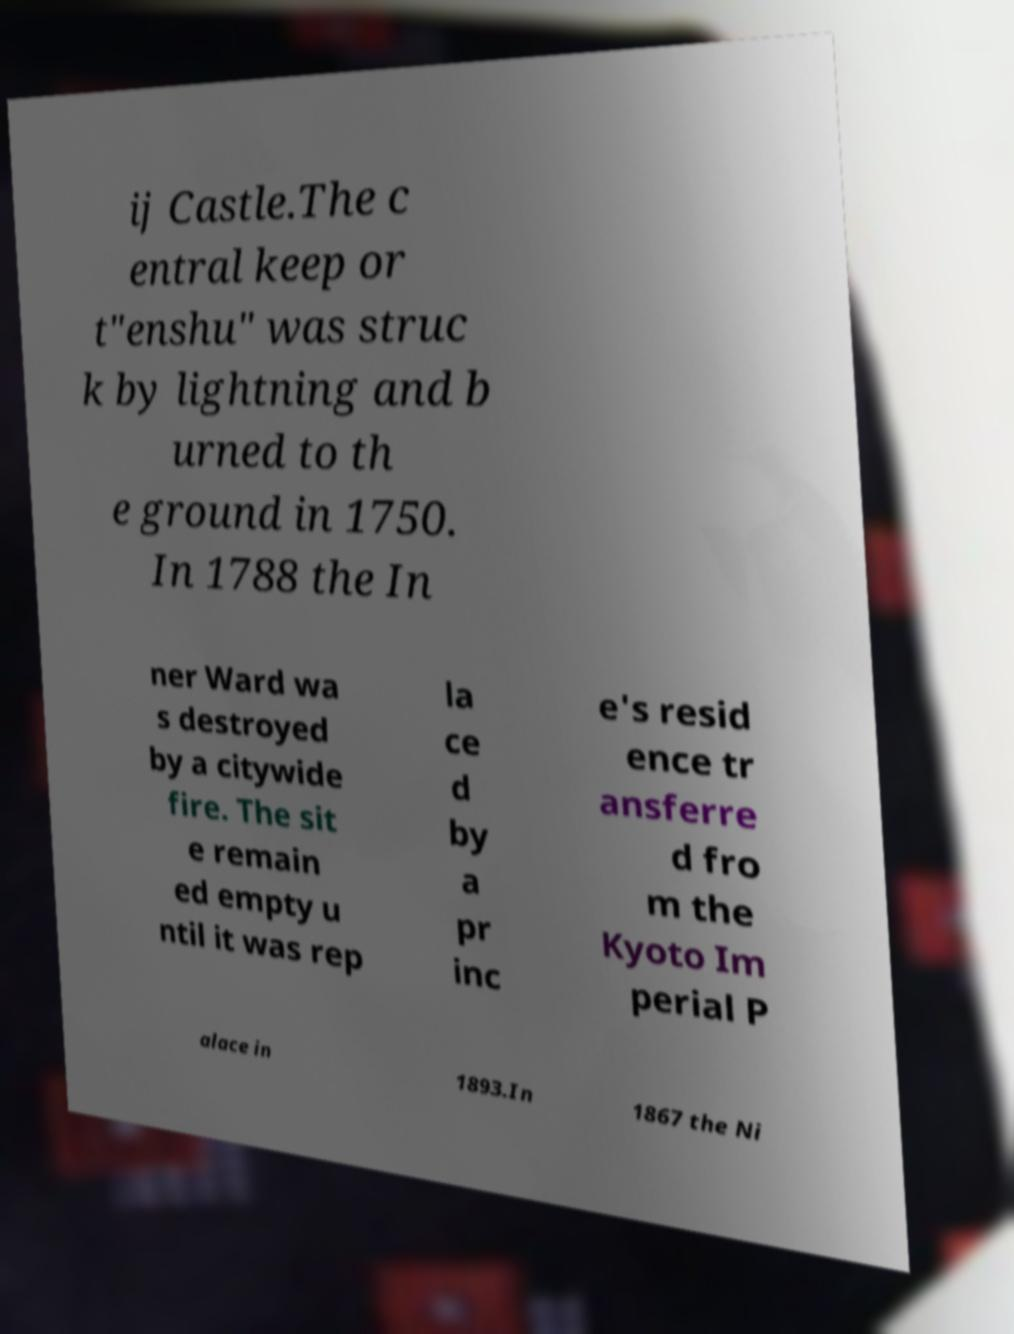Can you accurately transcribe the text from the provided image for me? ij Castle.The c entral keep or t"enshu" was struc k by lightning and b urned to th e ground in 1750. In 1788 the In ner Ward wa s destroyed by a citywide fire. The sit e remain ed empty u ntil it was rep la ce d by a pr inc e's resid ence tr ansferre d fro m the Kyoto Im perial P alace in 1893.In 1867 the Ni 